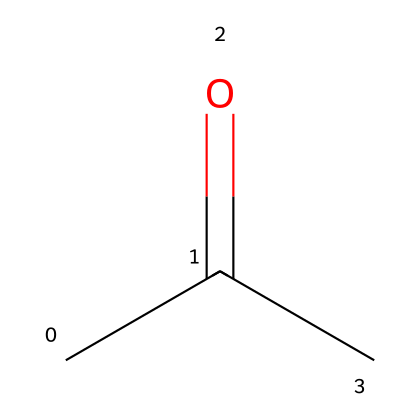What is the name of the chemical represented by this SMILES? The SMILES CC(=O)C corresponds to a chemical structure where a carbonyl group (C=O) is present, along with two methyl groups. This structure defines acetone.
Answer: acetone How many carbon atoms are in this compound? The SMILES shows three carbon atoms (C) in total: two from the methyl groups (CC) and one from the carbonyl (C=O).
Answer: three What type of functional group is present in acetone? The structure includes a carbonyl group (C=O). This functional group is characteristic of ketones, of which acetone is one.
Answer: carbonyl What is the degree of saturation for this chemical? Acetone contains one double bond (C=O), giving it a degree of saturation of one. No rings or other double bonds exist to contribute further to saturation.
Answer: one What is the boiling point range for acetone? Acetone, as a low-molecular-weight ketone, has a boiling point of approximately 56 to 57 degrees Celsius, which is notable for its volatility.
Answer: 56 to 57 degrees Celsius Is acetone polar or nonpolar? The presence of the carbonyl group contributes to acetone's polar characteristics due to the difference in electronegativity between carbon and oxygen, which results in a polar molecule overall.
Answer: polar What type of compound is acetone classified as? Acetone is classified as an aliphatic compound and specifically a ketone, as indicated by the structure with a carbonyl group located between two aliphatic carbon atoms.
Answer: ketone 